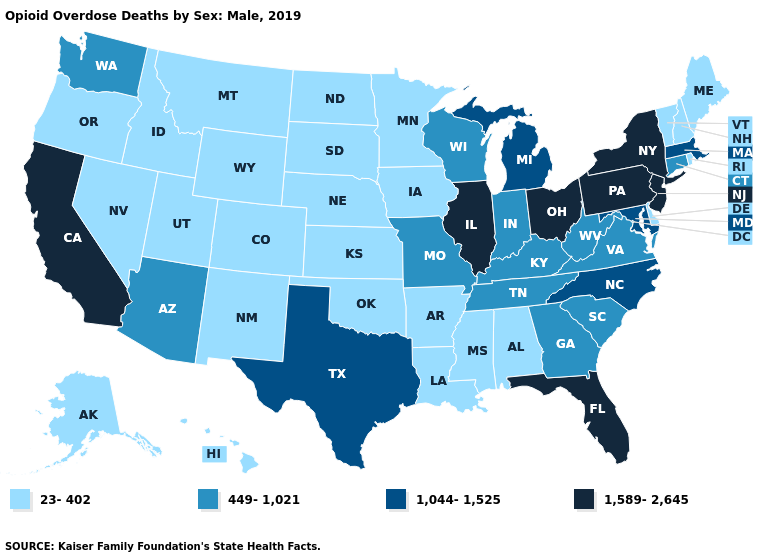Does New Jersey have a higher value than California?
Be succinct. No. Name the states that have a value in the range 23-402?
Concise answer only. Alabama, Alaska, Arkansas, Colorado, Delaware, Hawaii, Idaho, Iowa, Kansas, Louisiana, Maine, Minnesota, Mississippi, Montana, Nebraska, Nevada, New Hampshire, New Mexico, North Dakota, Oklahoma, Oregon, Rhode Island, South Dakota, Utah, Vermont, Wyoming. Does Minnesota have the lowest value in the USA?
Be succinct. Yes. Which states have the highest value in the USA?
Keep it brief. California, Florida, Illinois, New Jersey, New York, Ohio, Pennsylvania. What is the value of Virginia?
Answer briefly. 449-1,021. Name the states that have a value in the range 1,044-1,525?
Quick response, please. Maryland, Massachusetts, Michigan, North Carolina, Texas. What is the value of Hawaii?
Quick response, please. 23-402. Which states have the lowest value in the USA?
Give a very brief answer. Alabama, Alaska, Arkansas, Colorado, Delaware, Hawaii, Idaho, Iowa, Kansas, Louisiana, Maine, Minnesota, Mississippi, Montana, Nebraska, Nevada, New Hampshire, New Mexico, North Dakota, Oklahoma, Oregon, Rhode Island, South Dakota, Utah, Vermont, Wyoming. Is the legend a continuous bar?
Quick response, please. No. Among the states that border Oregon , which have the lowest value?
Short answer required. Idaho, Nevada. Name the states that have a value in the range 1,589-2,645?
Keep it brief. California, Florida, Illinois, New Jersey, New York, Ohio, Pennsylvania. Does the map have missing data?
Give a very brief answer. No. Does the first symbol in the legend represent the smallest category?
Keep it brief. Yes. Name the states that have a value in the range 23-402?
Concise answer only. Alabama, Alaska, Arkansas, Colorado, Delaware, Hawaii, Idaho, Iowa, Kansas, Louisiana, Maine, Minnesota, Mississippi, Montana, Nebraska, Nevada, New Hampshire, New Mexico, North Dakota, Oklahoma, Oregon, Rhode Island, South Dakota, Utah, Vermont, Wyoming. Name the states that have a value in the range 449-1,021?
Keep it brief. Arizona, Connecticut, Georgia, Indiana, Kentucky, Missouri, South Carolina, Tennessee, Virginia, Washington, West Virginia, Wisconsin. 